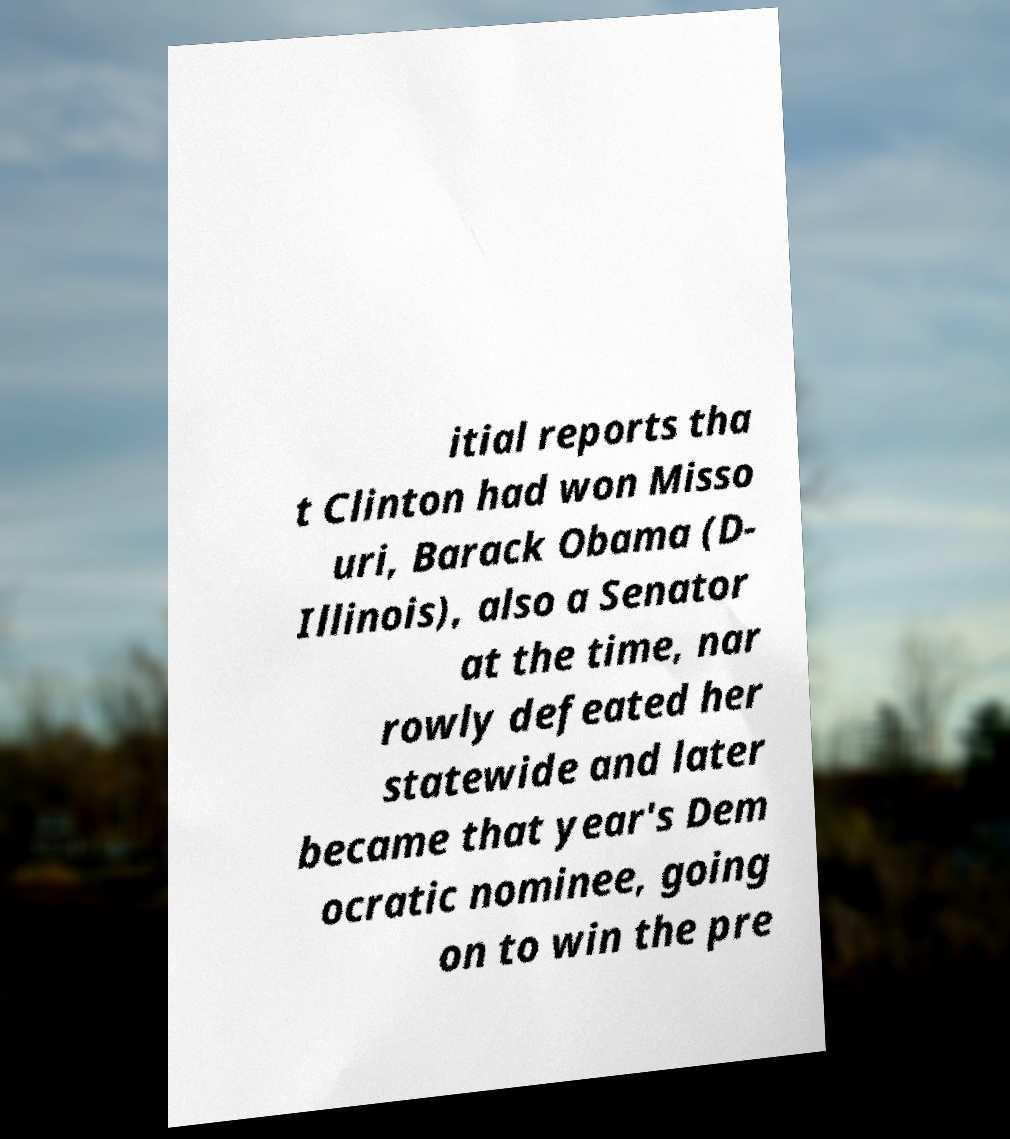Please read and relay the text visible in this image. What does it say? itial reports tha t Clinton had won Misso uri, Barack Obama (D- Illinois), also a Senator at the time, nar rowly defeated her statewide and later became that year's Dem ocratic nominee, going on to win the pre 